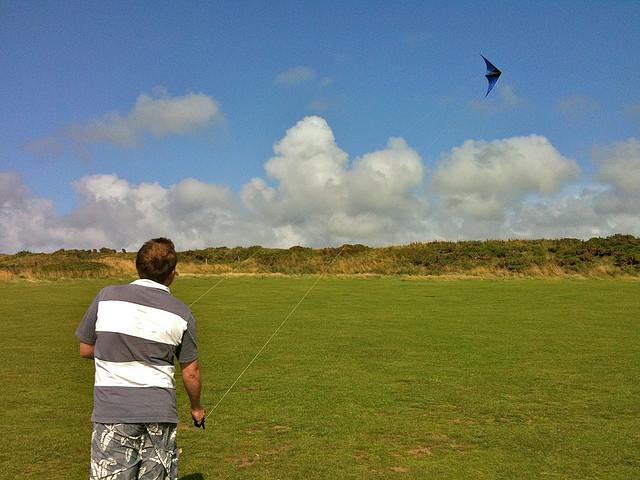Is the kite in the sky?
Be succinct. Yes. What style of shirt is he wearing?
Give a very brief answer. Polo. Is the shirt gray and  white striped?
Quick response, please. Yes. How high is the kite in the air?
Answer briefly. 30 feet. Are they on safari?
Write a very short answer. No. 